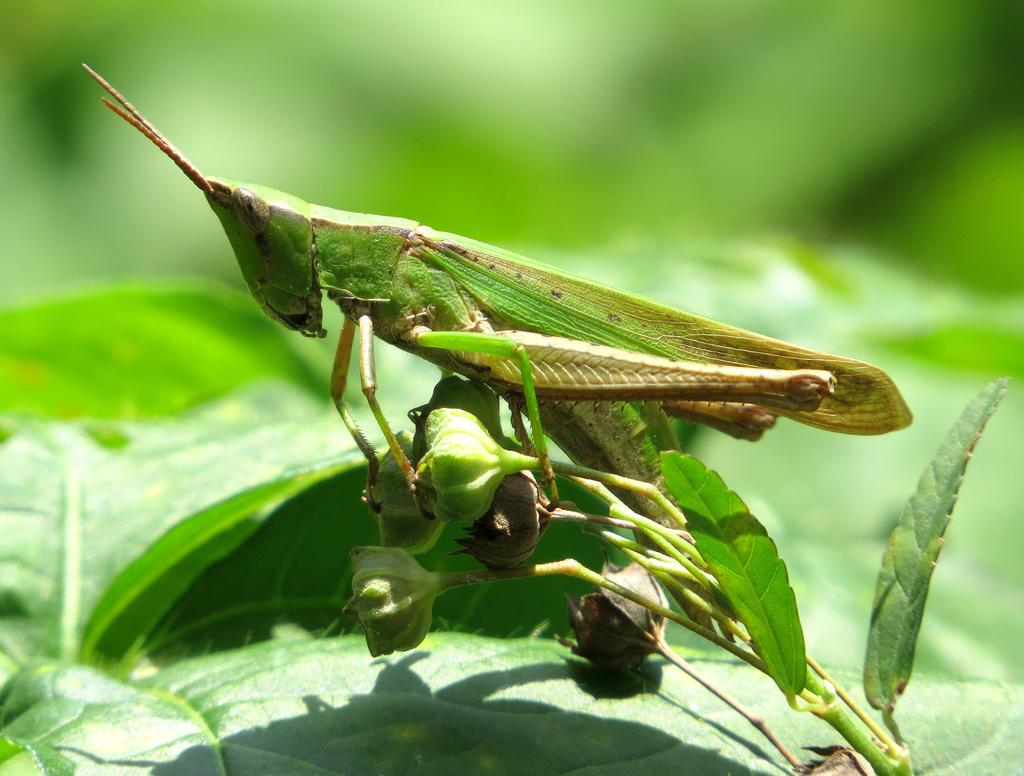What is the main subject of the picture? The main subject of the picture is a Grasshopper. Where is the Grasshopper located in the image? The Grasshopper is on a plant. What can be seen below the Grasshopper? There are green leaves below the Grasshopper. What type of cushion is the Grasshopper sitting on in the image? There is no cushion present in the image; the Grasshopper is on a plant. Can you see any horns on the Grasshopper in the image? Grasshoppers do not have horns, so there are none visible in the image. 